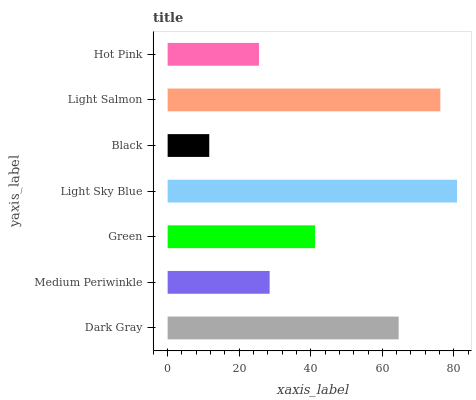Is Black the minimum?
Answer yes or no. Yes. Is Light Sky Blue the maximum?
Answer yes or no. Yes. Is Medium Periwinkle the minimum?
Answer yes or no. No. Is Medium Periwinkle the maximum?
Answer yes or no. No. Is Dark Gray greater than Medium Periwinkle?
Answer yes or no. Yes. Is Medium Periwinkle less than Dark Gray?
Answer yes or no. Yes. Is Medium Periwinkle greater than Dark Gray?
Answer yes or no. No. Is Dark Gray less than Medium Periwinkle?
Answer yes or no. No. Is Green the high median?
Answer yes or no. Yes. Is Green the low median?
Answer yes or no. Yes. Is Light Sky Blue the high median?
Answer yes or no. No. Is Light Salmon the low median?
Answer yes or no. No. 